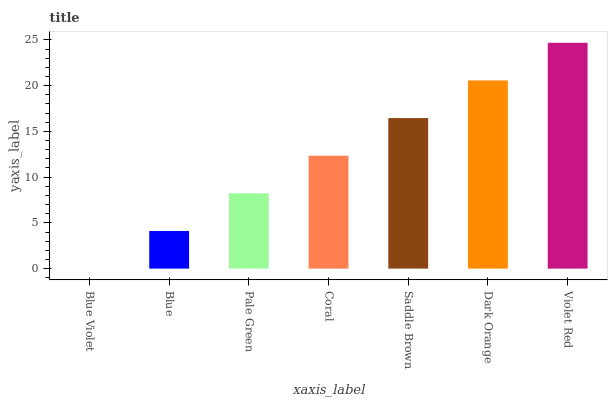Is Blue Violet the minimum?
Answer yes or no. Yes. Is Violet Red the maximum?
Answer yes or no. Yes. Is Blue the minimum?
Answer yes or no. No. Is Blue the maximum?
Answer yes or no. No. Is Blue greater than Blue Violet?
Answer yes or no. Yes. Is Blue Violet less than Blue?
Answer yes or no. Yes. Is Blue Violet greater than Blue?
Answer yes or no. No. Is Blue less than Blue Violet?
Answer yes or no. No. Is Coral the high median?
Answer yes or no. Yes. Is Coral the low median?
Answer yes or no. Yes. Is Pale Green the high median?
Answer yes or no. No. Is Dark Orange the low median?
Answer yes or no. No. 